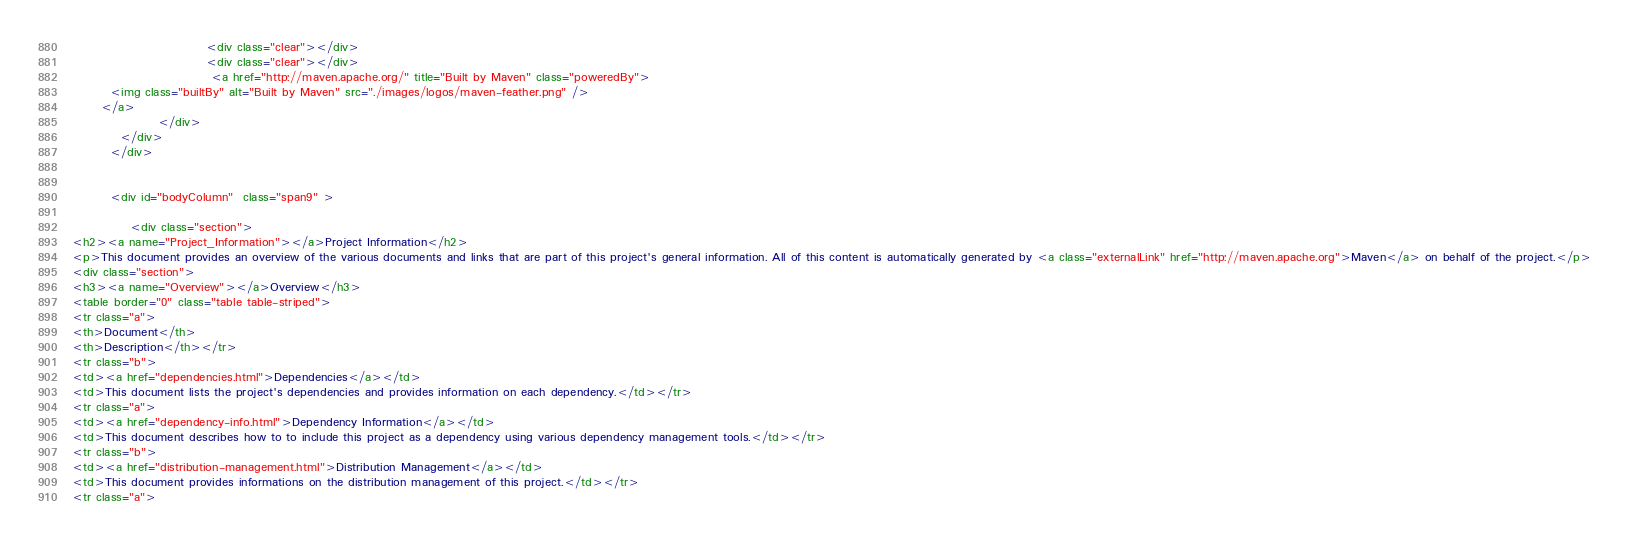<code> <loc_0><loc_0><loc_500><loc_500><_HTML_>                            <div class="clear"></div>
                            <div class="clear"></div>
                             <a href="http://maven.apache.org/" title="Built by Maven" class="poweredBy">
        <img class="builtBy" alt="Built by Maven" src="./images/logos/maven-feather.png" />
      </a>
                  </div>
          </div>
        </div>
        
                
        <div id="bodyColumn"  class="span9" >
                                  
            <div class="section">
<h2><a name="Project_Information"></a>Project Information</h2>
<p>This document provides an overview of the various documents and links that are part of this project's general information. All of this content is automatically generated by <a class="externalLink" href="http://maven.apache.org">Maven</a> on behalf of the project.</p>
<div class="section">
<h3><a name="Overview"></a>Overview</h3>
<table border="0" class="table table-striped">
<tr class="a">
<th>Document</th>
<th>Description</th></tr>
<tr class="b">
<td><a href="dependencies.html">Dependencies</a></td>
<td>This document lists the project's dependencies and provides information on each dependency.</td></tr>
<tr class="a">
<td><a href="dependency-info.html">Dependency Information</a></td>
<td>This document describes how to to include this project as a dependency using various dependency management tools.</td></tr>
<tr class="b">
<td><a href="distribution-management.html">Distribution Management</a></td>
<td>This document provides informations on the distribution management of this project.</td></tr>
<tr class="a"></code> 